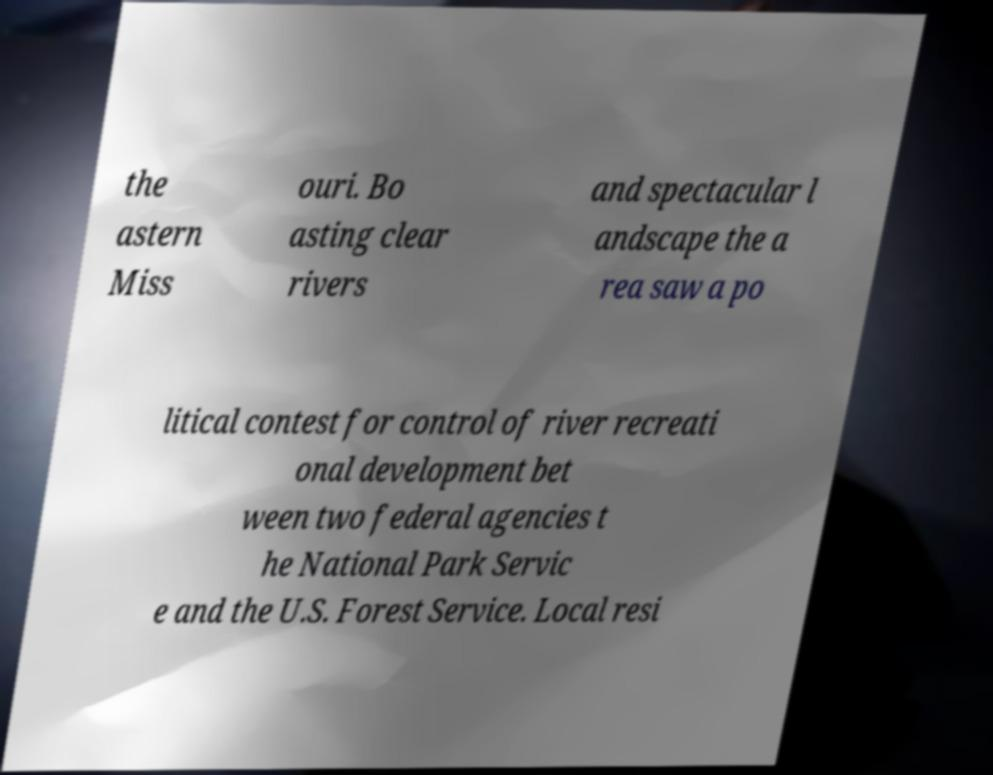For documentation purposes, I need the text within this image transcribed. Could you provide that? the astern Miss ouri. Bo asting clear rivers and spectacular l andscape the a rea saw a po litical contest for control of river recreati onal development bet ween two federal agencies t he National Park Servic e and the U.S. Forest Service. Local resi 